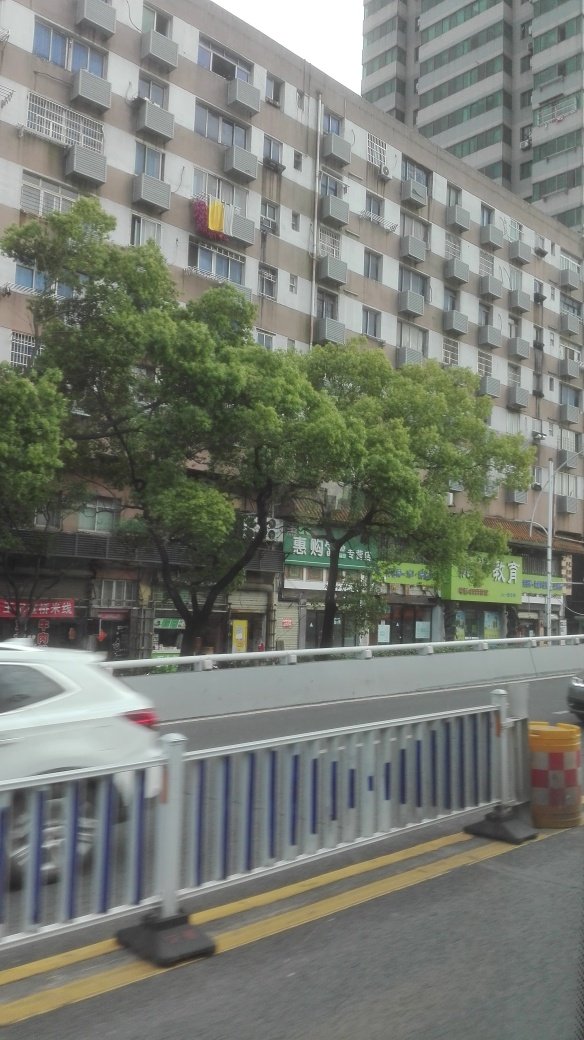Can you describe the setting of this image? The image captures an urban setting with a multi-story residential building that has several air conditioning units on its facade. Shops can be seen at street level below the apartments, and there is a mature tree in front of the building that adds a touch of nature to the scene. What can you infer about the climate or weather in this region based on the buildings? Given the presence of multiple air conditioning units, it suggests a climate with warm periods, where temperature control inside the buildings is important. The greenery of the tree also indicates that it's not an arid region, possibly one that receives enough rain to support tree growth. 